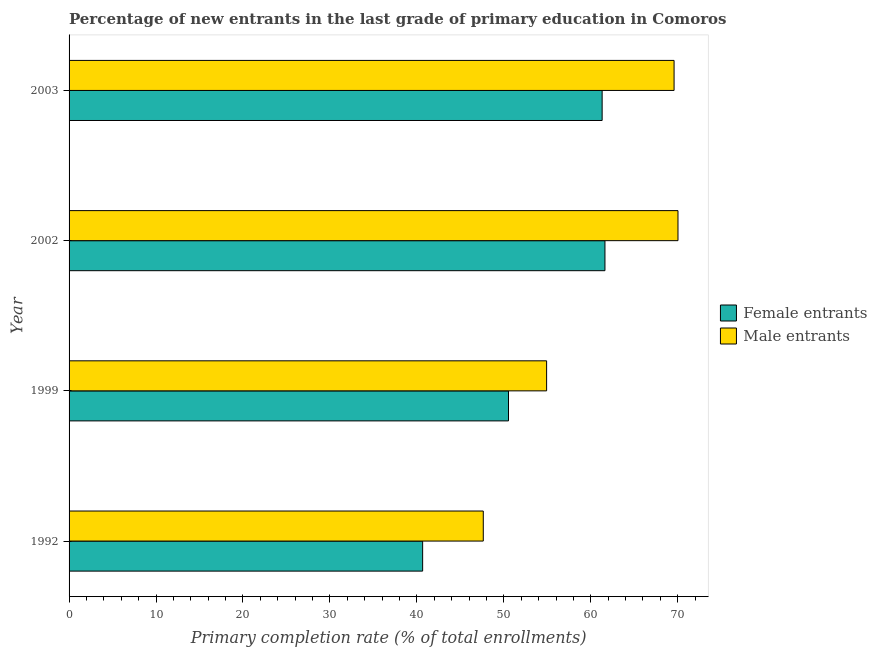Are the number of bars on each tick of the Y-axis equal?
Provide a succinct answer. Yes. What is the label of the 3rd group of bars from the top?
Offer a very short reply. 1999. What is the primary completion rate of female entrants in 2003?
Give a very brief answer. 61.31. Across all years, what is the maximum primary completion rate of female entrants?
Your answer should be very brief. 61.63. Across all years, what is the minimum primary completion rate of female entrants?
Offer a very short reply. 40.66. In which year was the primary completion rate of female entrants maximum?
Keep it short and to the point. 2002. What is the total primary completion rate of male entrants in the graph?
Make the answer very short. 242.16. What is the difference between the primary completion rate of female entrants in 2002 and that in 2003?
Give a very brief answer. 0.32. What is the difference between the primary completion rate of male entrants in 2003 and the primary completion rate of female entrants in 2002?
Your response must be concise. 7.95. What is the average primary completion rate of female entrants per year?
Offer a terse response. 53.53. In the year 2003, what is the difference between the primary completion rate of female entrants and primary completion rate of male entrants?
Provide a succinct answer. -8.27. What is the ratio of the primary completion rate of male entrants in 1999 to that in 2002?
Provide a succinct answer. 0.78. What is the difference between the highest and the second highest primary completion rate of female entrants?
Your answer should be compact. 0.32. What is the difference between the highest and the lowest primary completion rate of female entrants?
Offer a very short reply. 20.97. In how many years, is the primary completion rate of male entrants greater than the average primary completion rate of male entrants taken over all years?
Provide a short and direct response. 2. Is the sum of the primary completion rate of male entrants in 1992 and 1999 greater than the maximum primary completion rate of female entrants across all years?
Ensure brevity in your answer.  Yes. What does the 1st bar from the top in 2002 represents?
Provide a short and direct response. Male entrants. What does the 1st bar from the bottom in 2003 represents?
Offer a terse response. Female entrants. Are all the bars in the graph horizontal?
Your answer should be very brief. Yes. How many years are there in the graph?
Provide a succinct answer. 4. What is the difference between two consecutive major ticks on the X-axis?
Your answer should be compact. 10. Does the graph contain any zero values?
Offer a very short reply. No. Does the graph contain grids?
Offer a very short reply. No. How many legend labels are there?
Provide a short and direct response. 2. What is the title of the graph?
Offer a very short reply. Percentage of new entrants in the last grade of primary education in Comoros. Does "Commercial service exports" appear as one of the legend labels in the graph?
Offer a terse response. No. What is the label or title of the X-axis?
Your response must be concise. Primary completion rate (% of total enrollments). What is the Primary completion rate (% of total enrollments) in Female entrants in 1992?
Your answer should be very brief. 40.66. What is the Primary completion rate (% of total enrollments) of Male entrants in 1992?
Ensure brevity in your answer.  47.64. What is the Primary completion rate (% of total enrollments) of Female entrants in 1999?
Make the answer very short. 50.54. What is the Primary completion rate (% of total enrollments) in Male entrants in 1999?
Offer a very short reply. 54.92. What is the Primary completion rate (% of total enrollments) in Female entrants in 2002?
Your answer should be very brief. 61.63. What is the Primary completion rate (% of total enrollments) in Male entrants in 2002?
Provide a short and direct response. 70.03. What is the Primary completion rate (% of total enrollments) in Female entrants in 2003?
Offer a terse response. 61.31. What is the Primary completion rate (% of total enrollments) of Male entrants in 2003?
Provide a short and direct response. 69.58. Across all years, what is the maximum Primary completion rate (% of total enrollments) of Female entrants?
Provide a short and direct response. 61.63. Across all years, what is the maximum Primary completion rate (% of total enrollments) in Male entrants?
Your answer should be compact. 70.03. Across all years, what is the minimum Primary completion rate (% of total enrollments) in Female entrants?
Provide a succinct answer. 40.66. Across all years, what is the minimum Primary completion rate (% of total enrollments) of Male entrants?
Your response must be concise. 47.64. What is the total Primary completion rate (% of total enrollments) of Female entrants in the graph?
Ensure brevity in your answer.  214.13. What is the total Primary completion rate (% of total enrollments) of Male entrants in the graph?
Your response must be concise. 242.16. What is the difference between the Primary completion rate (% of total enrollments) of Female entrants in 1992 and that in 1999?
Offer a very short reply. -9.87. What is the difference between the Primary completion rate (% of total enrollments) of Male entrants in 1992 and that in 1999?
Offer a very short reply. -7.28. What is the difference between the Primary completion rate (% of total enrollments) in Female entrants in 1992 and that in 2002?
Offer a very short reply. -20.97. What is the difference between the Primary completion rate (% of total enrollments) in Male entrants in 1992 and that in 2002?
Offer a terse response. -22.39. What is the difference between the Primary completion rate (% of total enrollments) in Female entrants in 1992 and that in 2003?
Offer a very short reply. -20.64. What is the difference between the Primary completion rate (% of total enrollments) in Male entrants in 1992 and that in 2003?
Make the answer very short. -21.94. What is the difference between the Primary completion rate (% of total enrollments) in Female entrants in 1999 and that in 2002?
Your answer should be very brief. -11.09. What is the difference between the Primary completion rate (% of total enrollments) of Male entrants in 1999 and that in 2002?
Offer a very short reply. -15.11. What is the difference between the Primary completion rate (% of total enrollments) in Female entrants in 1999 and that in 2003?
Ensure brevity in your answer.  -10.77. What is the difference between the Primary completion rate (% of total enrollments) in Male entrants in 1999 and that in 2003?
Offer a very short reply. -14.66. What is the difference between the Primary completion rate (% of total enrollments) in Female entrants in 2002 and that in 2003?
Provide a short and direct response. 0.32. What is the difference between the Primary completion rate (% of total enrollments) in Male entrants in 2002 and that in 2003?
Your response must be concise. 0.45. What is the difference between the Primary completion rate (% of total enrollments) in Female entrants in 1992 and the Primary completion rate (% of total enrollments) in Male entrants in 1999?
Make the answer very short. -14.26. What is the difference between the Primary completion rate (% of total enrollments) in Female entrants in 1992 and the Primary completion rate (% of total enrollments) in Male entrants in 2002?
Make the answer very short. -29.37. What is the difference between the Primary completion rate (% of total enrollments) in Female entrants in 1992 and the Primary completion rate (% of total enrollments) in Male entrants in 2003?
Keep it short and to the point. -28.92. What is the difference between the Primary completion rate (% of total enrollments) in Female entrants in 1999 and the Primary completion rate (% of total enrollments) in Male entrants in 2002?
Your answer should be compact. -19.49. What is the difference between the Primary completion rate (% of total enrollments) in Female entrants in 1999 and the Primary completion rate (% of total enrollments) in Male entrants in 2003?
Provide a short and direct response. -19.04. What is the difference between the Primary completion rate (% of total enrollments) of Female entrants in 2002 and the Primary completion rate (% of total enrollments) of Male entrants in 2003?
Make the answer very short. -7.95. What is the average Primary completion rate (% of total enrollments) in Female entrants per year?
Your response must be concise. 53.53. What is the average Primary completion rate (% of total enrollments) of Male entrants per year?
Make the answer very short. 60.54. In the year 1992, what is the difference between the Primary completion rate (% of total enrollments) in Female entrants and Primary completion rate (% of total enrollments) in Male entrants?
Offer a terse response. -6.97. In the year 1999, what is the difference between the Primary completion rate (% of total enrollments) in Female entrants and Primary completion rate (% of total enrollments) in Male entrants?
Your answer should be compact. -4.38. In the year 2002, what is the difference between the Primary completion rate (% of total enrollments) of Female entrants and Primary completion rate (% of total enrollments) of Male entrants?
Your answer should be very brief. -8.4. In the year 2003, what is the difference between the Primary completion rate (% of total enrollments) in Female entrants and Primary completion rate (% of total enrollments) in Male entrants?
Make the answer very short. -8.27. What is the ratio of the Primary completion rate (% of total enrollments) in Female entrants in 1992 to that in 1999?
Make the answer very short. 0.8. What is the ratio of the Primary completion rate (% of total enrollments) in Male entrants in 1992 to that in 1999?
Your answer should be compact. 0.87. What is the ratio of the Primary completion rate (% of total enrollments) of Female entrants in 1992 to that in 2002?
Offer a terse response. 0.66. What is the ratio of the Primary completion rate (% of total enrollments) of Male entrants in 1992 to that in 2002?
Provide a short and direct response. 0.68. What is the ratio of the Primary completion rate (% of total enrollments) of Female entrants in 1992 to that in 2003?
Ensure brevity in your answer.  0.66. What is the ratio of the Primary completion rate (% of total enrollments) of Male entrants in 1992 to that in 2003?
Your answer should be very brief. 0.68. What is the ratio of the Primary completion rate (% of total enrollments) of Female entrants in 1999 to that in 2002?
Keep it short and to the point. 0.82. What is the ratio of the Primary completion rate (% of total enrollments) in Male entrants in 1999 to that in 2002?
Offer a very short reply. 0.78. What is the ratio of the Primary completion rate (% of total enrollments) of Female entrants in 1999 to that in 2003?
Provide a short and direct response. 0.82. What is the ratio of the Primary completion rate (% of total enrollments) of Male entrants in 1999 to that in 2003?
Ensure brevity in your answer.  0.79. What is the ratio of the Primary completion rate (% of total enrollments) of Male entrants in 2002 to that in 2003?
Provide a short and direct response. 1.01. What is the difference between the highest and the second highest Primary completion rate (% of total enrollments) of Female entrants?
Your answer should be compact. 0.32. What is the difference between the highest and the second highest Primary completion rate (% of total enrollments) of Male entrants?
Offer a very short reply. 0.45. What is the difference between the highest and the lowest Primary completion rate (% of total enrollments) in Female entrants?
Your answer should be very brief. 20.97. What is the difference between the highest and the lowest Primary completion rate (% of total enrollments) in Male entrants?
Ensure brevity in your answer.  22.39. 